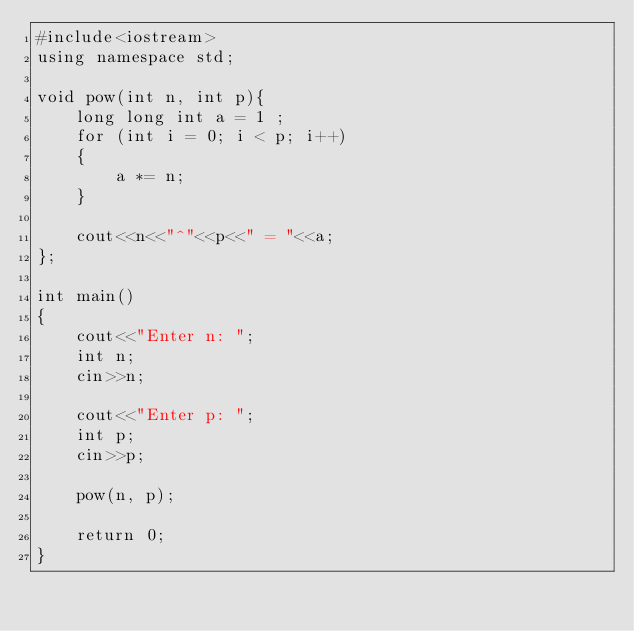<code> <loc_0><loc_0><loc_500><loc_500><_C++_>#include<iostream>
using namespace std;

void pow(int n, int p){
    long long int a = 1 ;
    for (int i = 0; i < p; i++)
    {
        a *= n; 
    }
    
    cout<<n<<"^"<<p<<" = "<<a;
};

int main()
{
    cout<<"Enter n: ";
    int n;
    cin>>n;

    cout<<"Enter p: ";
    int p;
    cin>>p;

    pow(n, p);

    return 0;
}</code> 